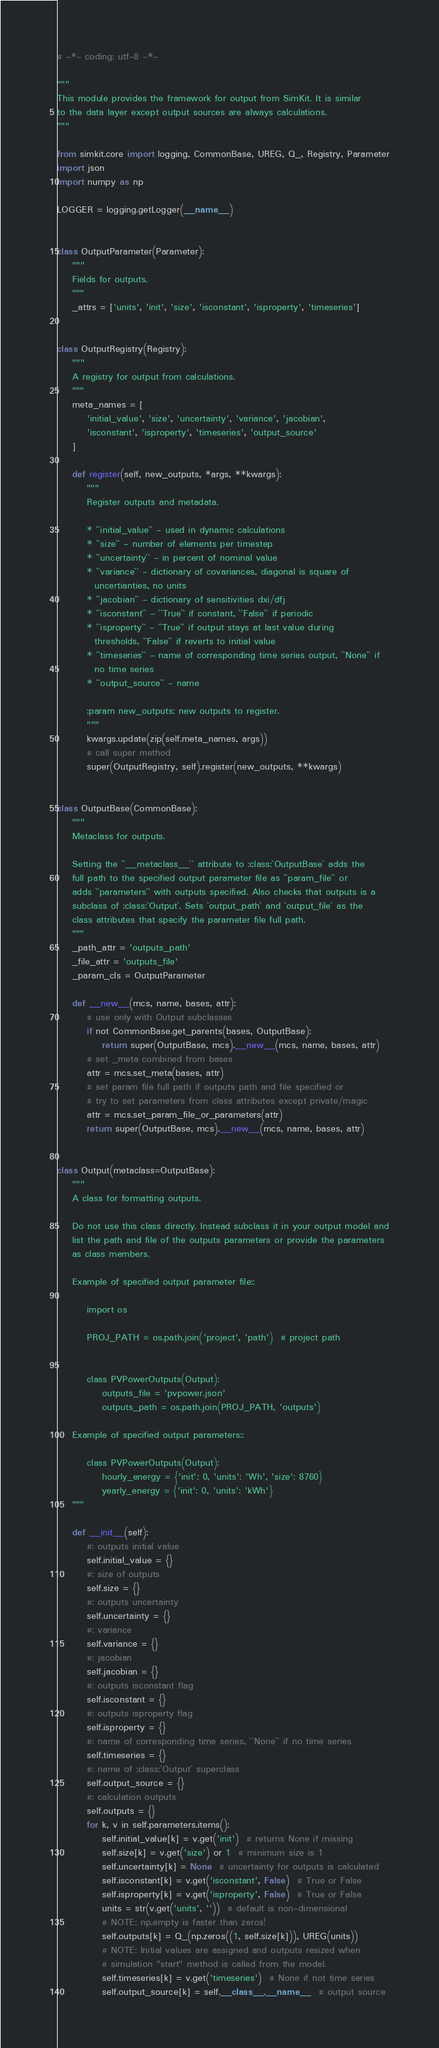<code> <loc_0><loc_0><loc_500><loc_500><_Python_># -*- coding: utf-8 -*-

"""
This module provides the framework for output from SimKit. It is similar
to the data layer except output sources are always calculations.
"""

from simkit.core import logging, CommonBase, UREG, Q_, Registry, Parameter
import json
import numpy as np

LOGGER = logging.getLogger(__name__)


class OutputParameter(Parameter):
    """
    Fields for outputs.
    """
    _attrs = ['units', 'init', 'size', 'isconstant', 'isproperty', 'timeseries']


class OutputRegistry(Registry):
    """
    A registry for output from calculations.
    """
    meta_names = [
        'initial_value', 'size', 'uncertainty', 'variance', 'jacobian',
        'isconstant', 'isproperty', 'timeseries', 'output_source'
    ]

    def register(self, new_outputs, *args, **kwargs):
        """
        Register outputs and metadata.

        * ``initial_value`` - used in dynamic calculations
        * ``size`` - number of elements per timestep
        * ``uncertainty`` - in percent of nominal value
        * ``variance`` - dictionary of covariances, diagonal is square of
          uncertianties, no units
        * ``jacobian`` - dictionary of sensitivities dxi/dfj
        * ``isconstant`` - ``True`` if constant, ``False`` if periodic
        * ``isproperty`` - ``True`` if output stays at last value during
          thresholds, ``False`` if reverts to initial value
        * ``timeseries`` - name of corresponding time series output, ``None`` if
          no time series
        * ``output_source`` - name

        :param new_outputs: new outputs to register.
        """
        kwargs.update(zip(self.meta_names, args))
        # call super method
        super(OutputRegistry, self).register(new_outputs, **kwargs)


class OutputBase(CommonBase):
    """
    Metaclass for outputs.

    Setting the ``__metaclass__`` attribute to :class:`OutputBase` adds the
    full path to the specified output parameter file as ``param_file`` or
    adds ``parameters`` with outputs specified. Also checks that outputs is a
    subclass of :class:`Output`. Sets `output_path` and `output_file` as the
    class attributes that specify the parameter file full path.
    """
    _path_attr = 'outputs_path'
    _file_attr = 'outputs_file'
    _param_cls = OutputParameter

    def __new__(mcs, name, bases, attr):
        # use only with Output subclasses
        if not CommonBase.get_parents(bases, OutputBase):
            return super(OutputBase, mcs).__new__(mcs, name, bases, attr)
        # set _meta combined from bases
        attr = mcs.set_meta(bases, attr)
        # set param file full path if outputs path and file specified or
        # try to set parameters from class attributes except private/magic
        attr = mcs.set_param_file_or_parameters(attr)
        return super(OutputBase, mcs).__new__(mcs, name, bases, attr)


class Output(metaclass=OutputBase):
    """
    A class for formatting outputs.

    Do not use this class directly. Instead subclass it in your output model and
    list the path and file of the outputs parameters or provide the parameters
    as class members.

    Example of specified output parameter file::

        import os

        PROJ_PATH = os.path.join('project', 'path')  # project path


        class PVPowerOutputs(Output):
            outputs_file = 'pvpower.json'
            outputs_path = os.path.join(PROJ_PATH, 'outputs')

    Example of specified output parameters::

        class PVPowerOutputs(Output):
            hourly_energy = {'init': 0, 'units': 'Wh', 'size': 8760}
            yearly_energy = {'init': 0, 'units': 'kWh'}
    """

    def __init__(self):
        #: outputs initial value
        self.initial_value = {}
        #: size of outputs
        self.size = {}
        #: outputs uncertainty
        self.uncertainty = {}
        #: variance
        self.variance = {}
        #: jacobian
        self.jacobian = {}
        #: outputs isconstant flag
        self.isconstant = {}
        #: outputs isproperty flag
        self.isproperty = {}
        #: name of corresponding time series, ``None`` if no time series
        self.timeseries = {}
        #: name of :class:`Output` superclass
        self.output_source = {}
        #: calculation outputs
        self.outputs = {}
        for k, v in self.parameters.items():
            self.initial_value[k] = v.get('init')  # returns None if missing
            self.size[k] = v.get('size') or 1  # minimum size is 1
            self.uncertainty[k] = None  # uncertainty for outputs is calculated
            self.isconstant[k] = v.get('isconstant', False)  # True or False
            self.isproperty[k] = v.get('isproperty', False)  # True or False
            units = str(v.get('units', ''))  # default is non-dimensional
            # NOTE: np.empty is faster than zeros!
            self.outputs[k] = Q_(np.zeros((1, self.size[k])), UREG(units))
            # NOTE: Initial values are assigned and outputs resized when
            # simulation "start" method is called from the model.
            self.timeseries[k] = v.get('timeseries')  # None if not time series
            self.output_source[k] = self.__class__.__name__  # output source
</code> 